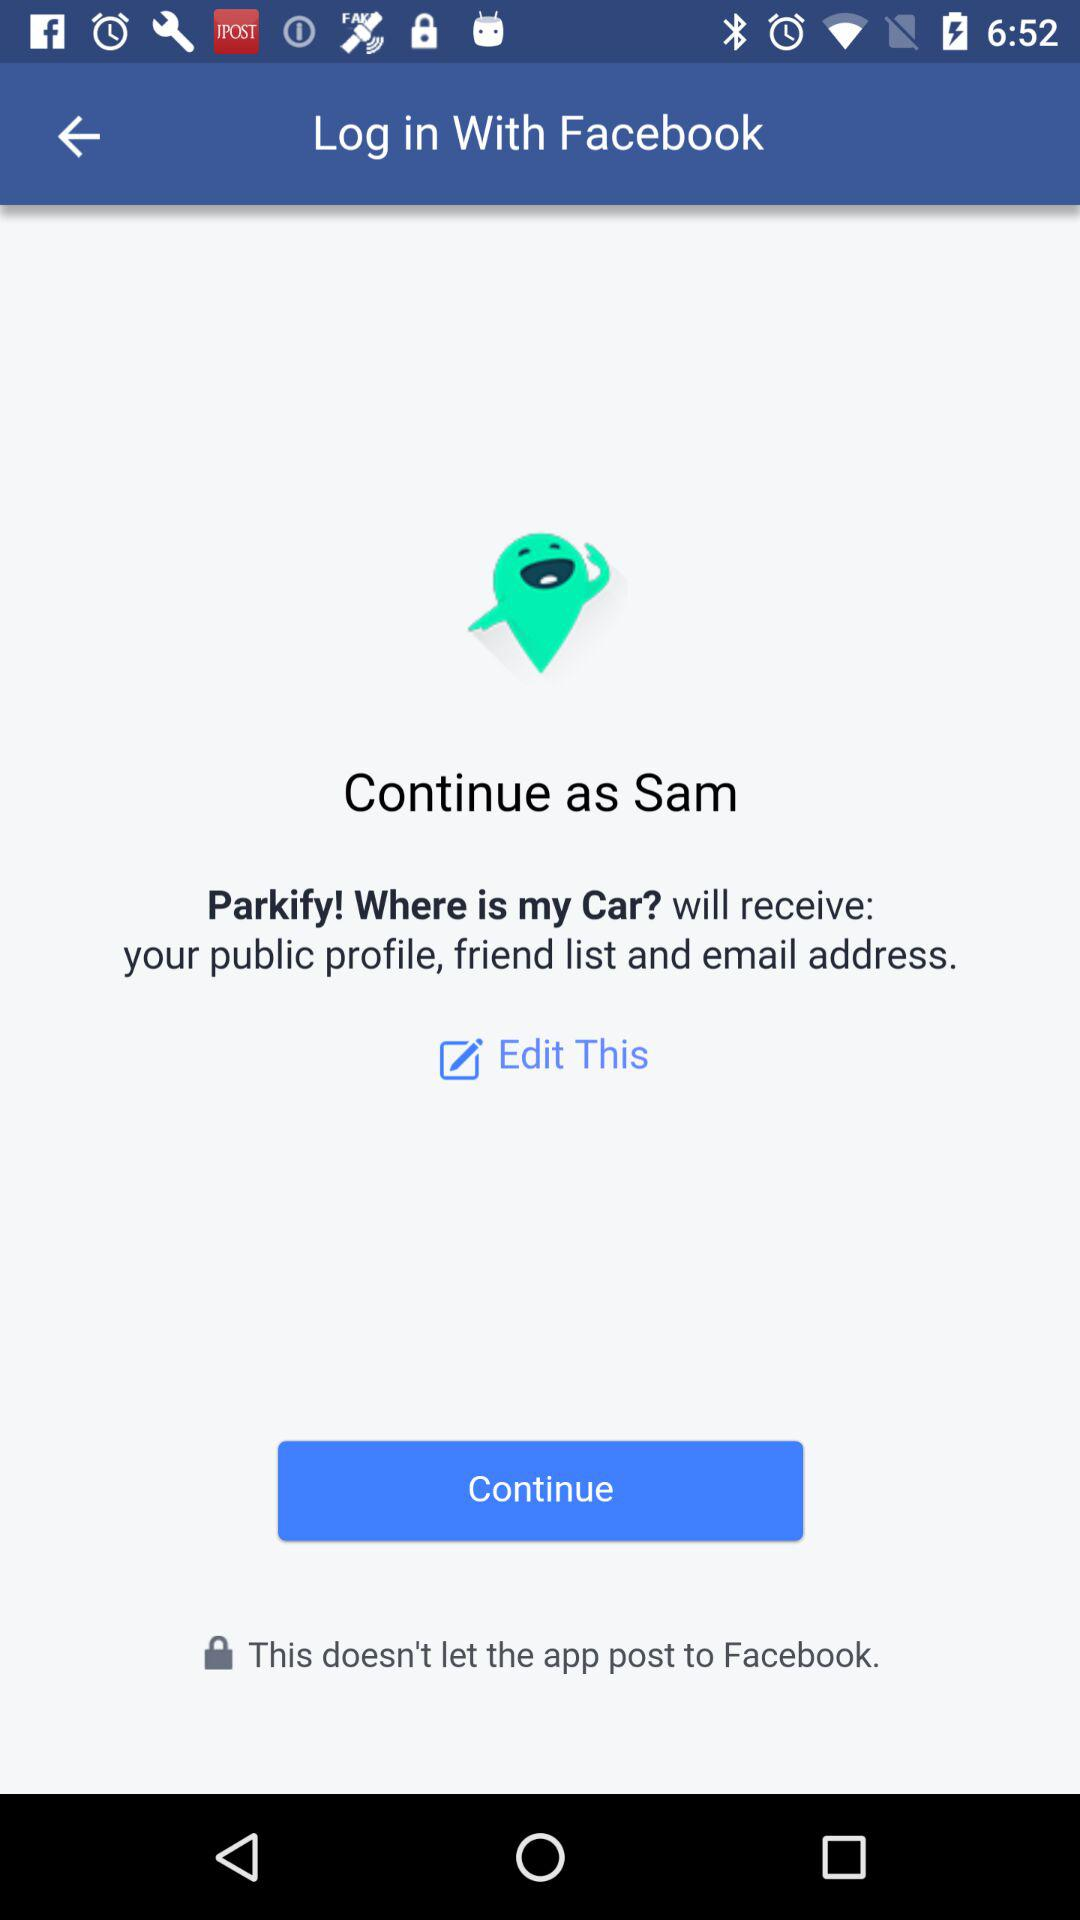What information will "Parkify! Where is my car?" received? "Parkify! Where is my car?" will receive your public profile, friend list and email address. 